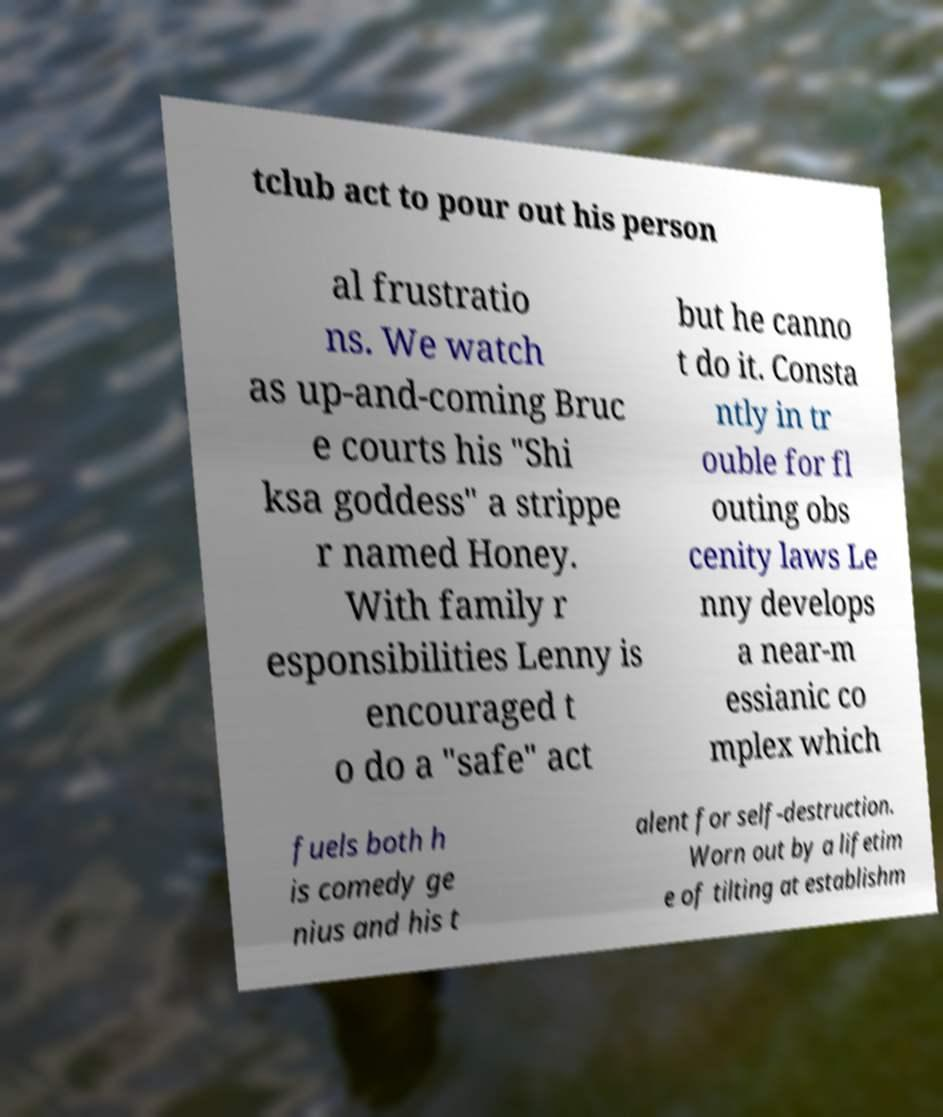I need the written content from this picture converted into text. Can you do that? tclub act to pour out his person al frustratio ns. We watch as up-and-coming Bruc e courts his "Shi ksa goddess" a strippe r named Honey. With family r esponsibilities Lenny is encouraged t o do a "safe" act but he canno t do it. Consta ntly in tr ouble for fl outing obs cenity laws Le nny develops a near-m essianic co mplex which fuels both h is comedy ge nius and his t alent for self-destruction. Worn out by a lifetim e of tilting at establishm 